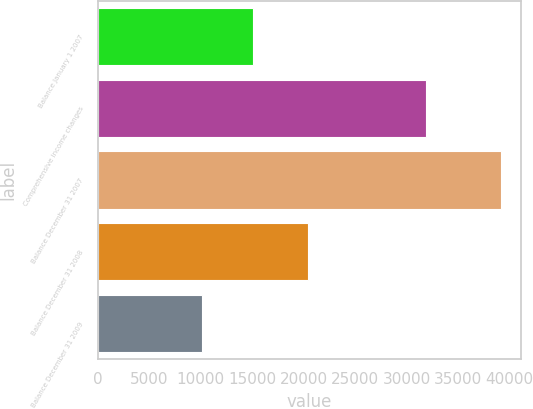<chart> <loc_0><loc_0><loc_500><loc_500><bar_chart><fcel>Balance January 1 2007<fcel>Comprehensive income changes<fcel>Balance December 31 2007<fcel>Balance December 31 2008<fcel>Balance December 31 2009<nl><fcel>15028.4<fcel>31925.4<fcel>39128<fcel>20454<fcel>10078<nl></chart> 